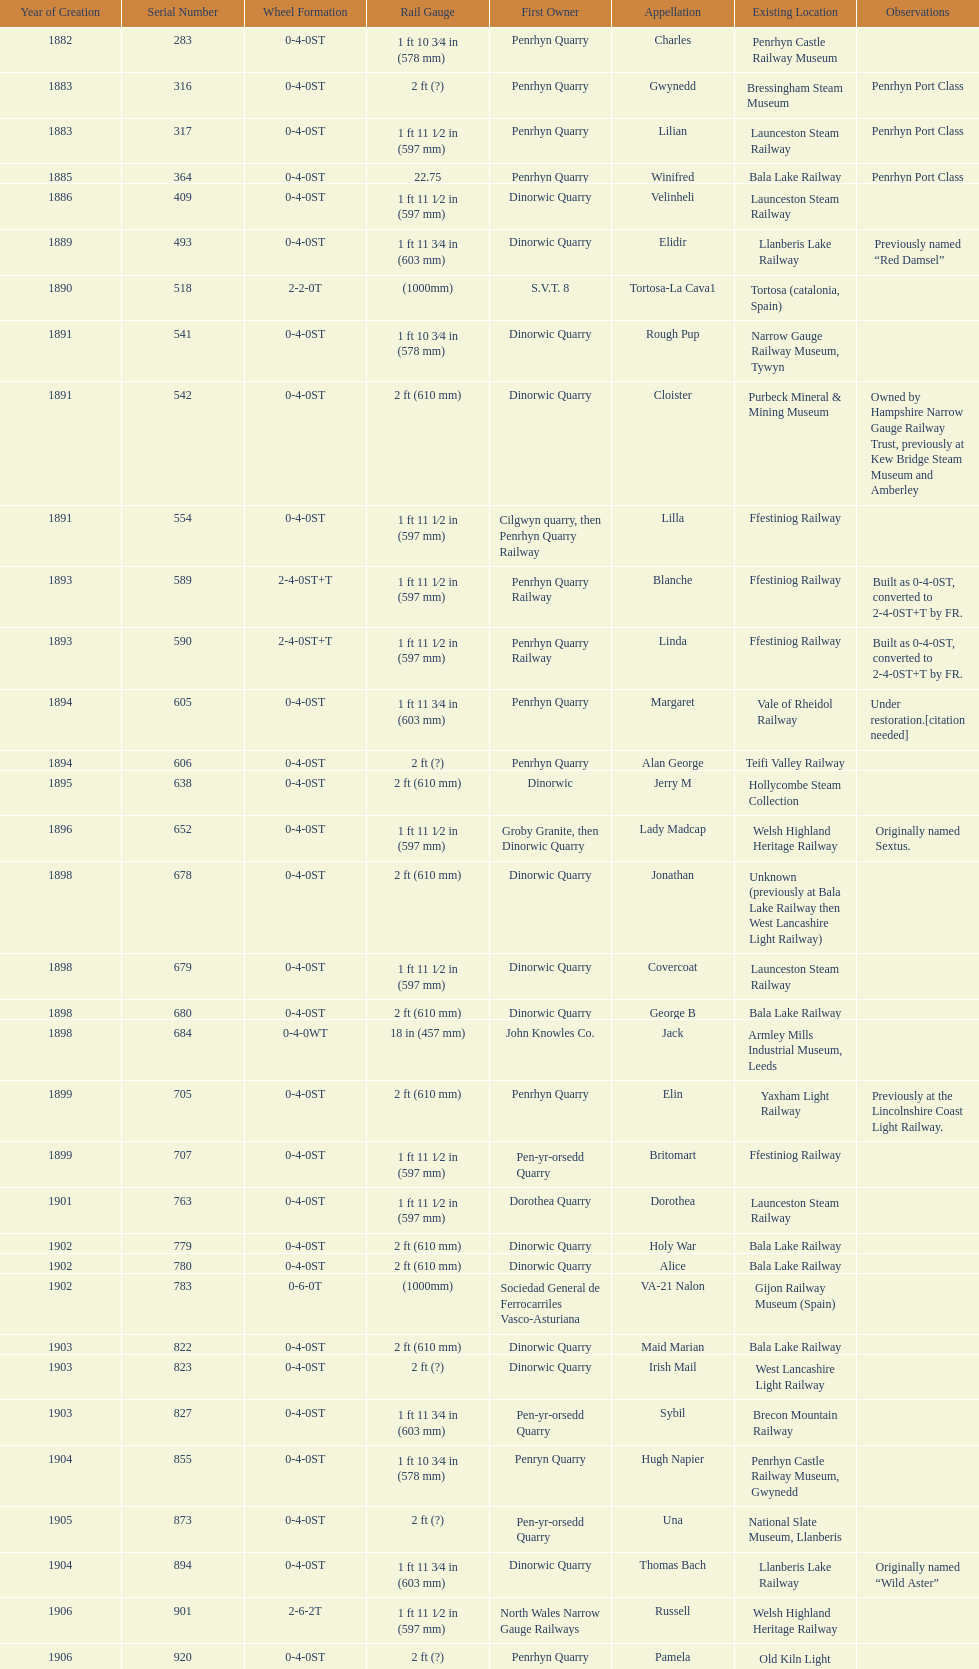What is the difference in gauge between works numbers 541 and 542? 32 mm. 